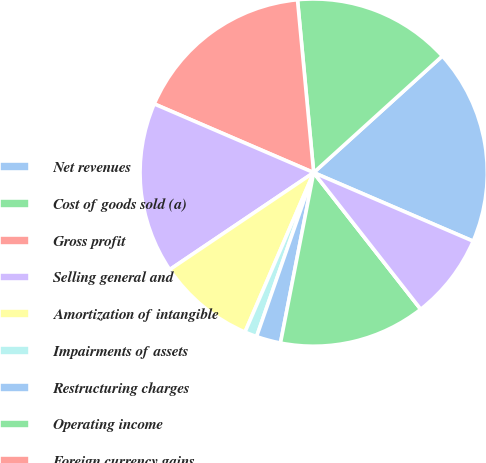Convert chart to OTSL. <chart><loc_0><loc_0><loc_500><loc_500><pie_chart><fcel>Net revenues<fcel>Cost of goods sold (a)<fcel>Gross profit<fcel>Selling general and<fcel>Amortization of intangible<fcel>Impairments of assets<fcel>Restructuring charges<fcel>Operating income<fcel>Foreign currency gains<fcel>Interest expense<nl><fcel>18.18%<fcel>14.77%<fcel>17.04%<fcel>15.91%<fcel>9.09%<fcel>1.14%<fcel>2.27%<fcel>13.64%<fcel>0.0%<fcel>7.96%<nl></chart> 